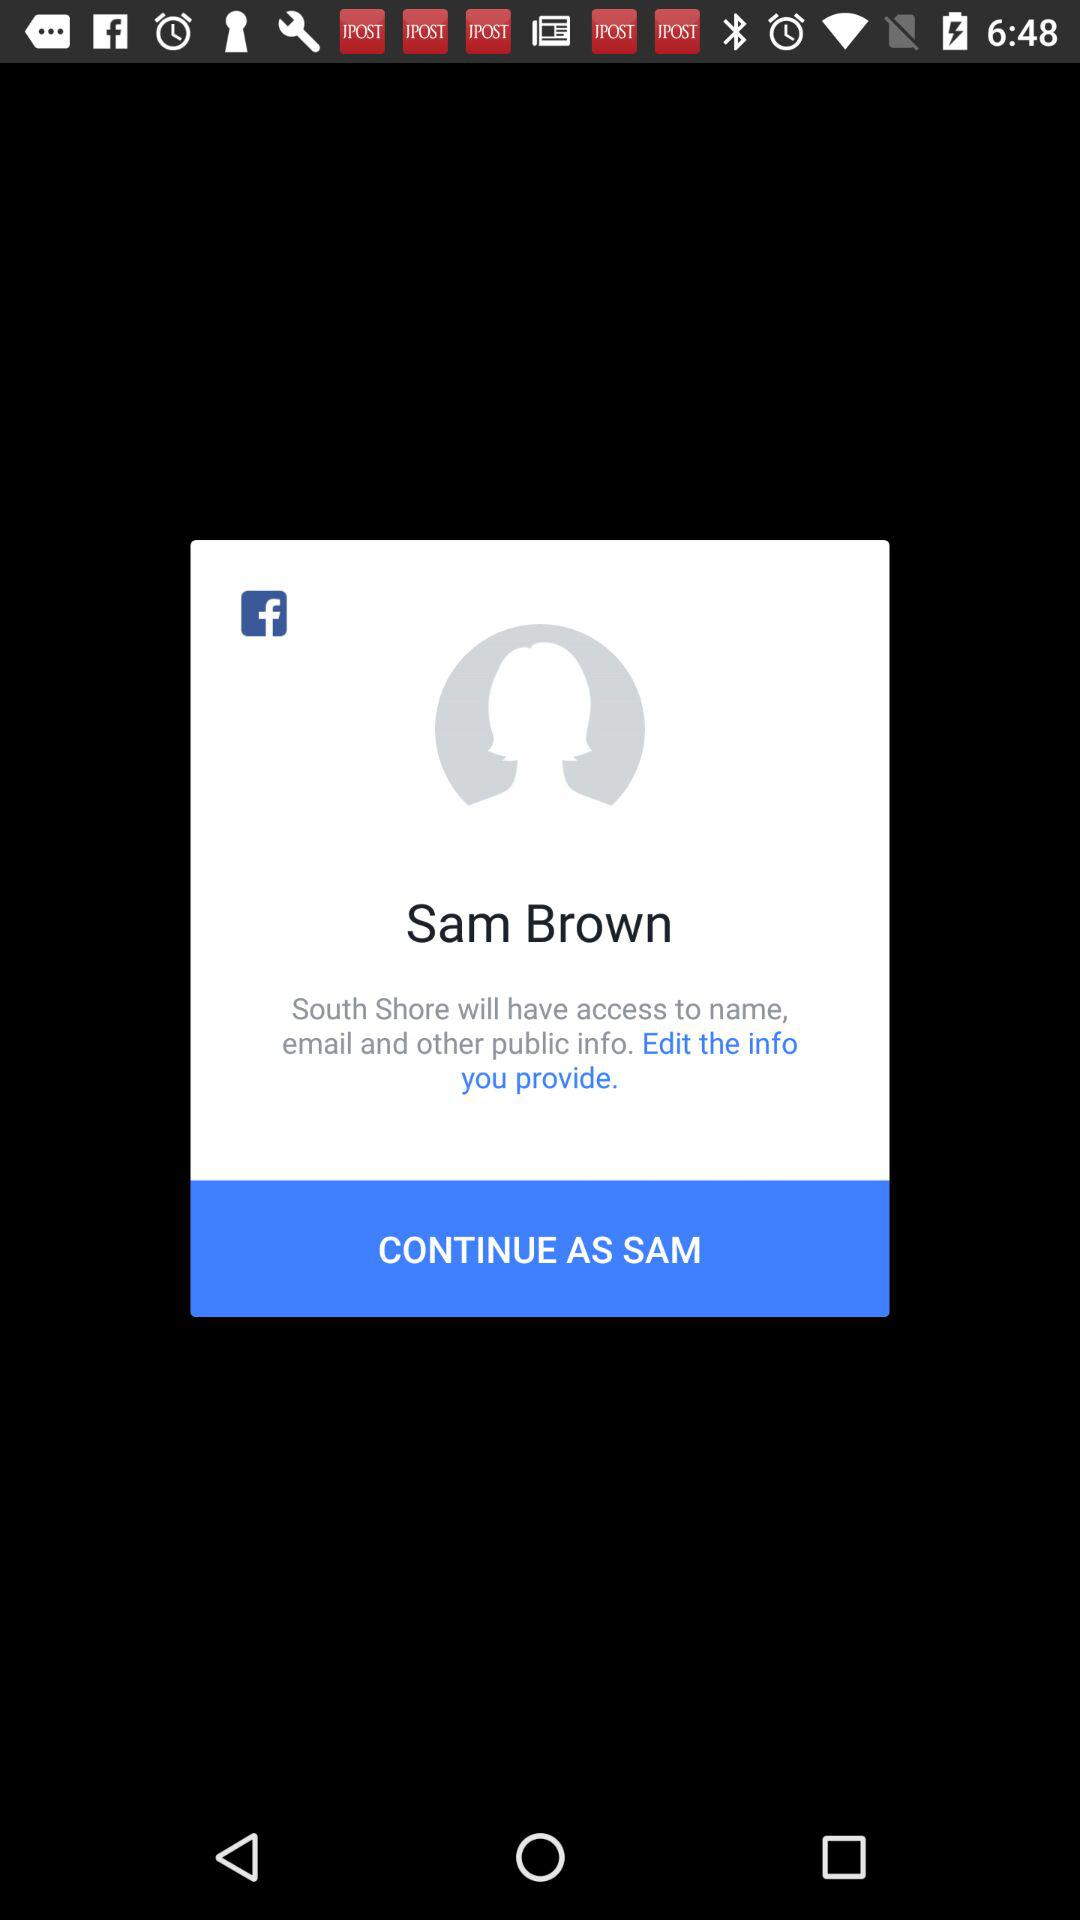What application is asking for permission? The application asking for permission is "South Shore". 